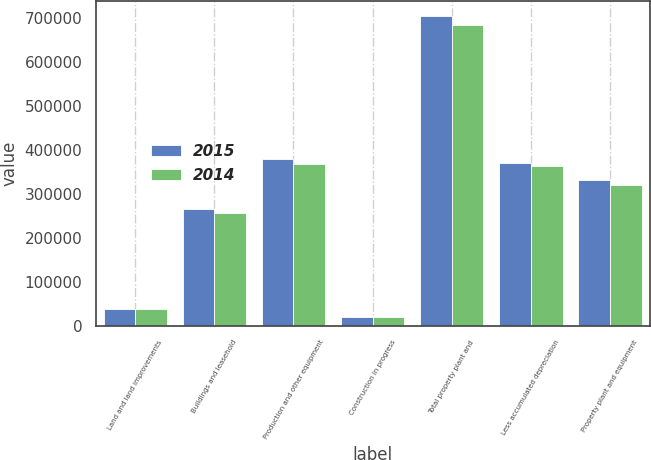Convert chart to OTSL. <chart><loc_0><loc_0><loc_500><loc_500><stacked_bar_chart><ecel><fcel>Land and land improvements<fcel>Buildings and leasehold<fcel>Production and other equipment<fcel>Construction in progress<fcel>Total property plant and<fcel>Less accumulated depreciation<fcel>Property plant and equipment<nl><fcel>2015<fcel>38735<fcel>265300<fcel>380016<fcel>20477<fcel>704528<fcel>371173<fcel>333355<nl><fcel>2014<fcel>39688<fcel>256603<fcel>367716<fcel>20606<fcel>684613<fcel>363030<fcel>321583<nl></chart> 